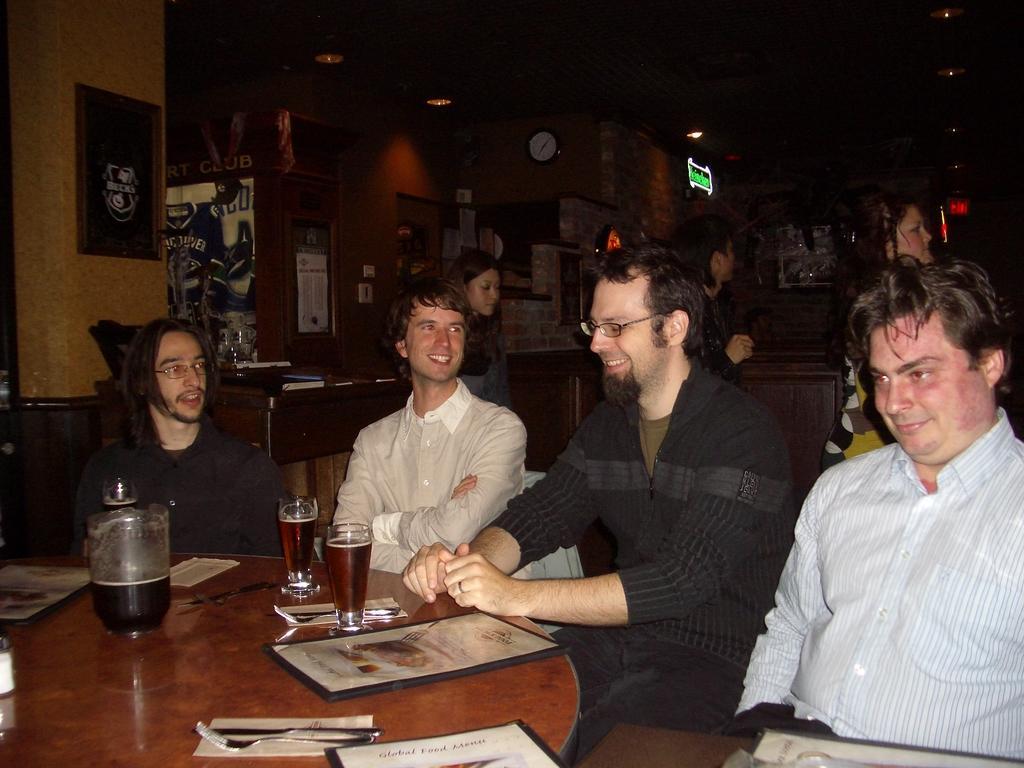Describe this image in one or two sentences. As we can see in the image there is a wall, photo frame, clock, few people sitting on chairs and there is a table. On table there fork, spoon, frame, glass and paper. 